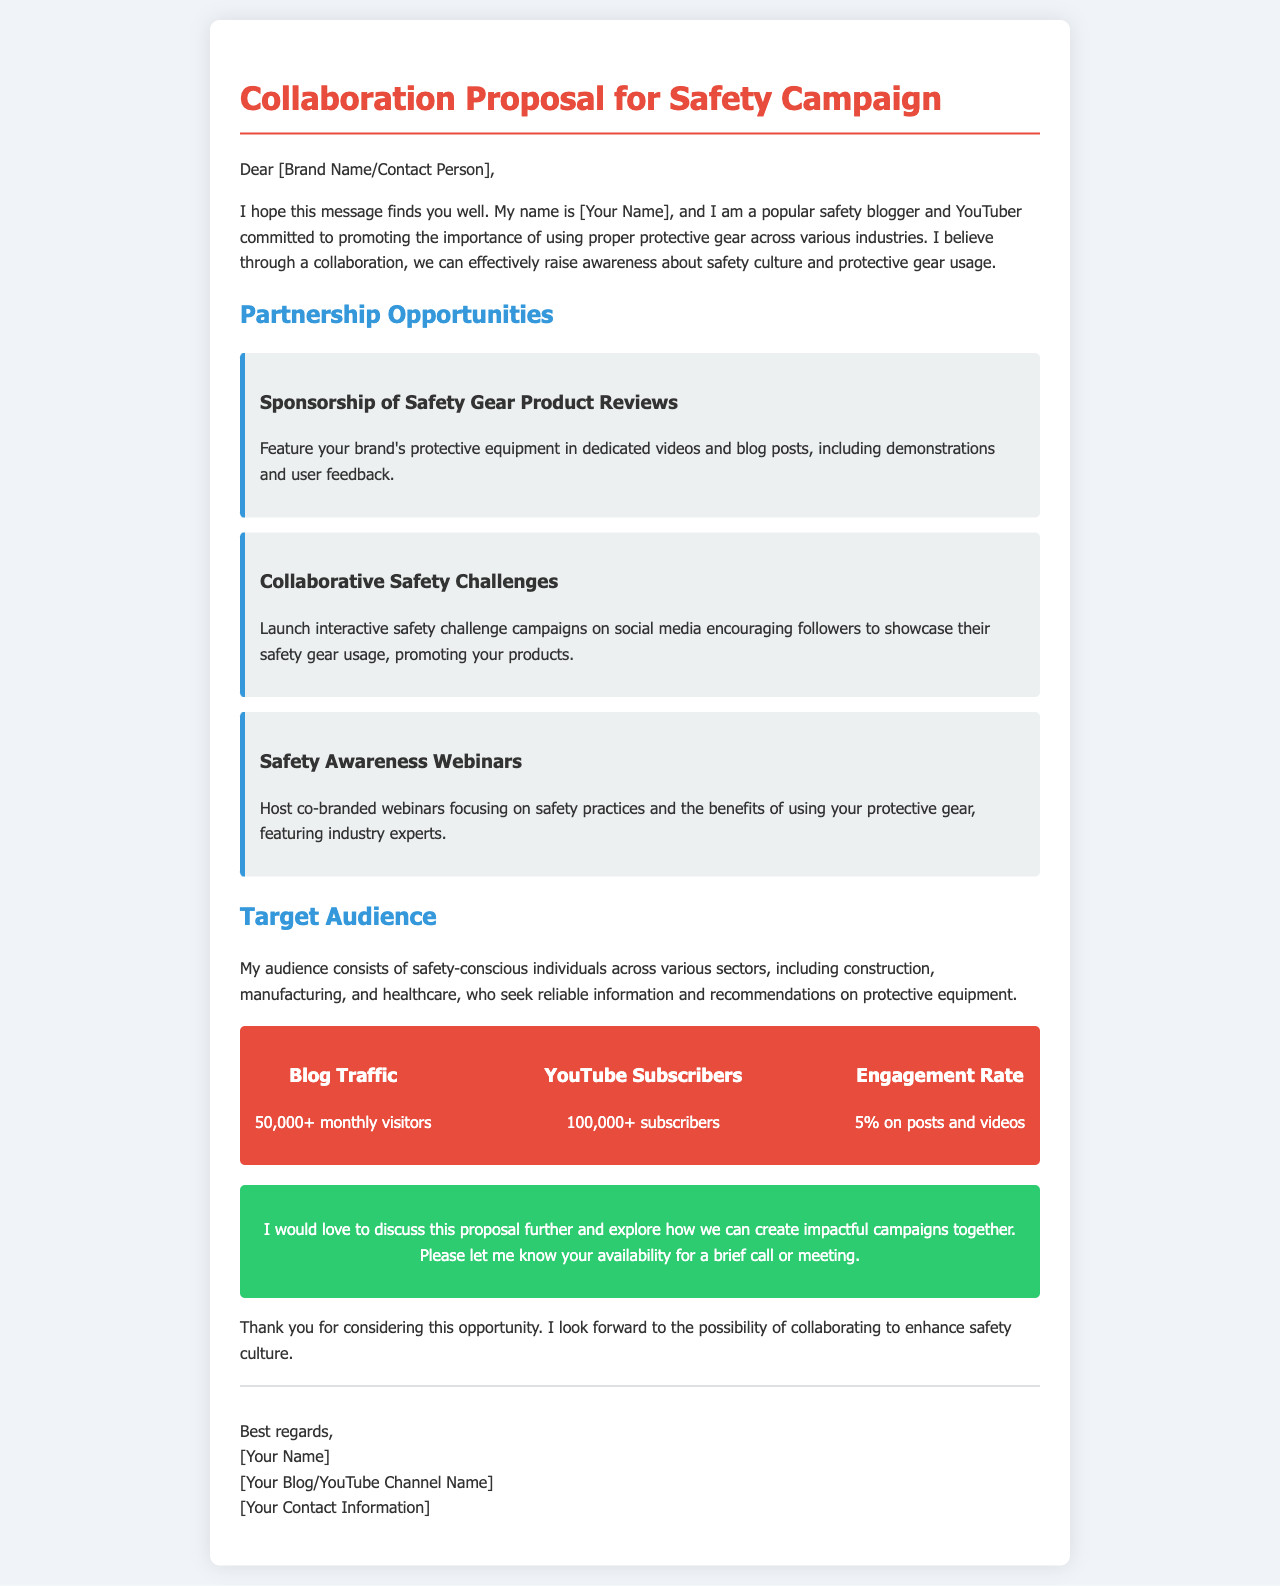What is the title of the proposal? The title of the proposal is found at the top of the document.
Answer: Collaboration Proposal for Safety Campaign Who is the author of the proposal? The author introduces themselves at the beginning of the document.
Answer: [Your Name] What is the monthly blog traffic? The monthly blog traffic is one of the metrics provided.
Answer: 50,000+ monthly visitors How many YouTube subscribers are mentioned? The number of YouTube subscribers is listed in the metrics section.
Answer: 100,000+ subscribers What type of challenges are proposed for collaboration? The specific type of challenges is mentioned in the partnership opportunities section.
Answer: Safety Challenges What is the engagement rate on posts and videos? The engagement rate is another metric detailed in the proposal.
Answer: 5% on posts and videos What is the primary goal of the collaboration? The goal is stated in the introduction of the email.
Answer: Raise awareness about safety culture and protective gear usage What specific event is suggested to promote safety practices? The event type is outlined under partnership opportunities.
Answer: Safety Awareness Webinars How does the author wish to proceed with the proposal? The intention for further discussion is expressed in the call-to-action section.
Answer: Discuss this proposal further 